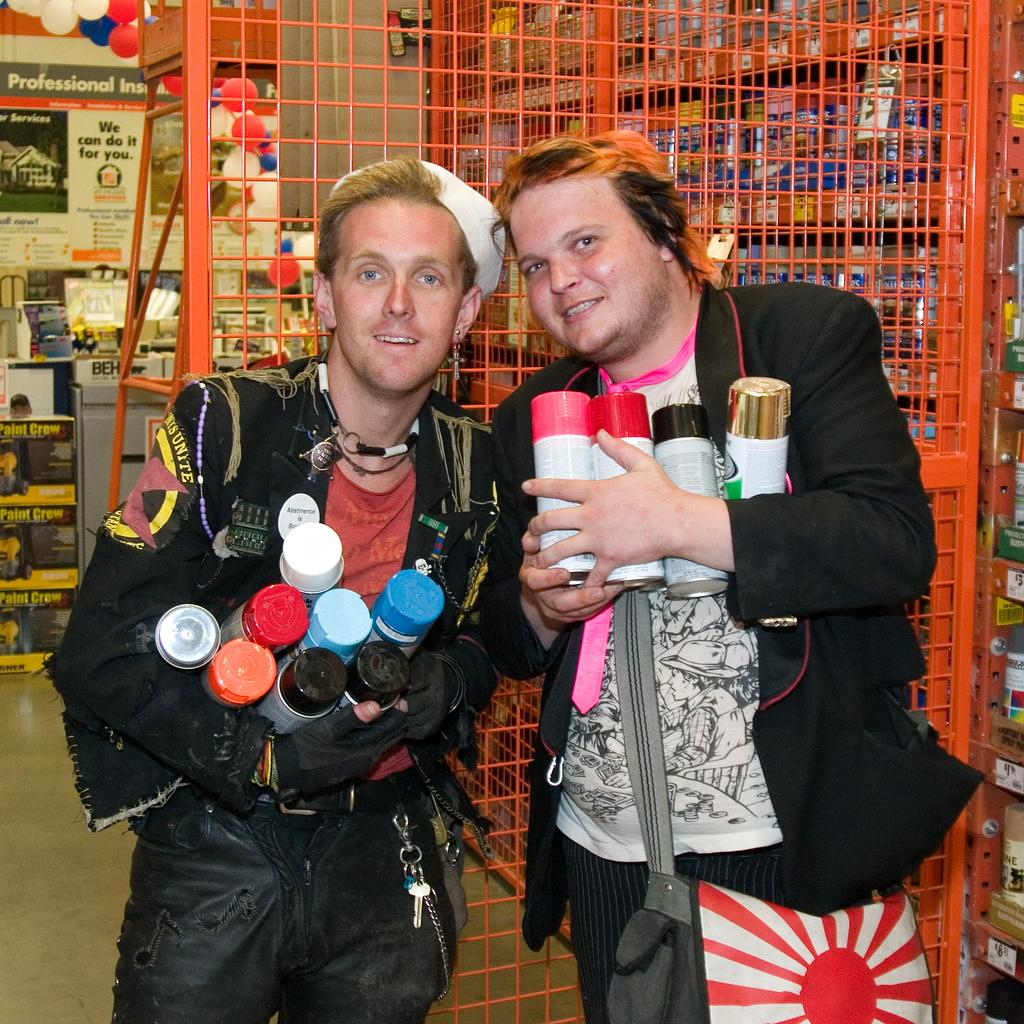How many people are present in the image? There are two people standing in the image. What are the people holding in their hands? The people are holding bottles. What can be seen in the background of the image? There are objects in racks in the background. What type of barrier is visible in the image? There is an orange gate visible. What is on the floor in the image? There are objects on the floor. Can you see a crown on the head of one of the people in the image? No, there is no crown visible on the head of either person in the image. 